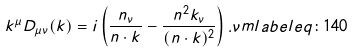<formula> <loc_0><loc_0><loc_500><loc_500>k ^ { \mu } D _ { \mu \nu } ( k ) = i \left ( \frac { n _ { \nu } } { n \cdot k } - \frac { n ^ { 2 } k _ { \nu } } { ( n \cdot k ) ^ { 2 } } \right ) . \nu m l a b e l { e q \colon 1 4 0 }</formula> 